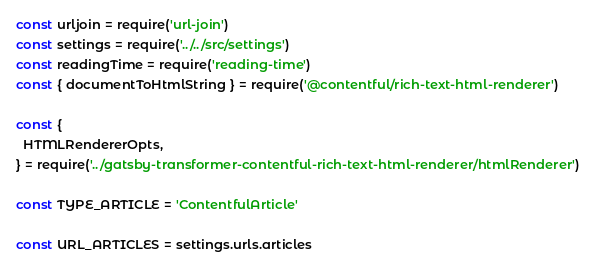<code> <loc_0><loc_0><loc_500><loc_500><_JavaScript_>const urljoin = require('url-join')
const settings = require('../../src/settings')
const readingTime = require('reading-time')
const { documentToHtmlString } = require('@contentful/rich-text-html-renderer')

const {
  HTMLRendererOpts,
} = require('../gatsby-transformer-contentful-rich-text-html-renderer/htmlRenderer')

const TYPE_ARTICLE = 'ContentfulArticle'

const URL_ARTICLES = settings.urls.articles
</code> 